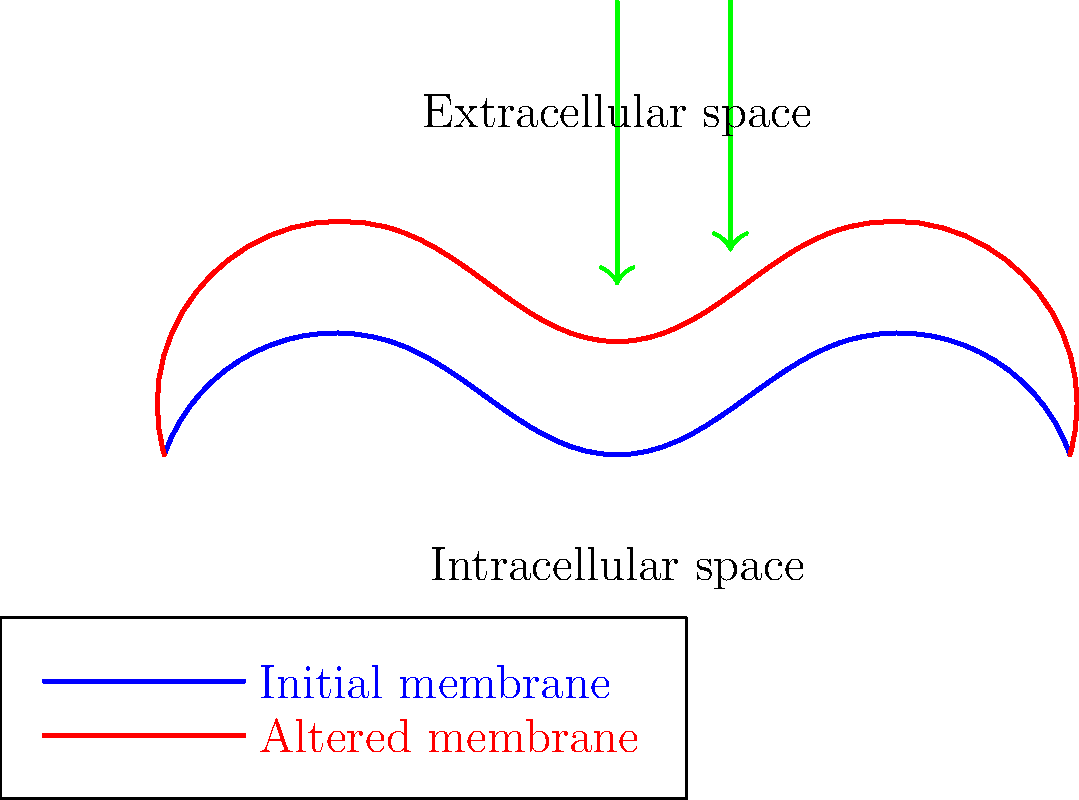Consider the topological changes in a cell membrane during the absorption of a natural supplement. The blue line represents the initial membrane state, and the red line shows the altered membrane state after supplement interaction. Which of the following best describes the observed membrane alteration?

A) Membrane invagination
B) Membrane fluidization
C) Membrane fusion
D) Membrane budding To answer this question, let's analyze the topological changes shown in the diagram:

1. Initial state (blue line): The membrane has a relatively smooth, wavy structure.

2. Altered state (red line): The membrane shows increased curvature and more pronounced undulations.

3. Comparing the two states:
   a) There is no inward folding or pocket formation, ruling out invagination.
   b) The membrane maintains its continuity, so fusion is not occurring.
   c) There is no outward budding or vesicle formation visible.

4. The key observation is the increased flexibility and movement of the membrane, indicated by the more pronounced curves and undulations in the red line.

5. This increased movement and flexibility is characteristic of membrane fluidization, where the lipid bilayer becomes more fluid and mobile due to the interaction with the supplement molecules.

6. Membrane fluidization can occur when certain supplements, especially those with lipophilic properties, interact with the lipid bilayer. This interaction can disrupt the tight packing of lipid molecules, increasing their mobility and the overall fluidity of the membrane.

7. Increased membrane fluidity can facilitate the absorption of supplements by:
   a) Allowing easier insertion of supplement molecules into the membrane.
   b) Enhancing the movement of transport proteins within the membrane.
   c) Potentially increasing the permeability of the membrane to certain molecules.

Therefore, the best description of the observed membrane alteration is membrane fluidization (option B).
Answer: B) Membrane fluidization 